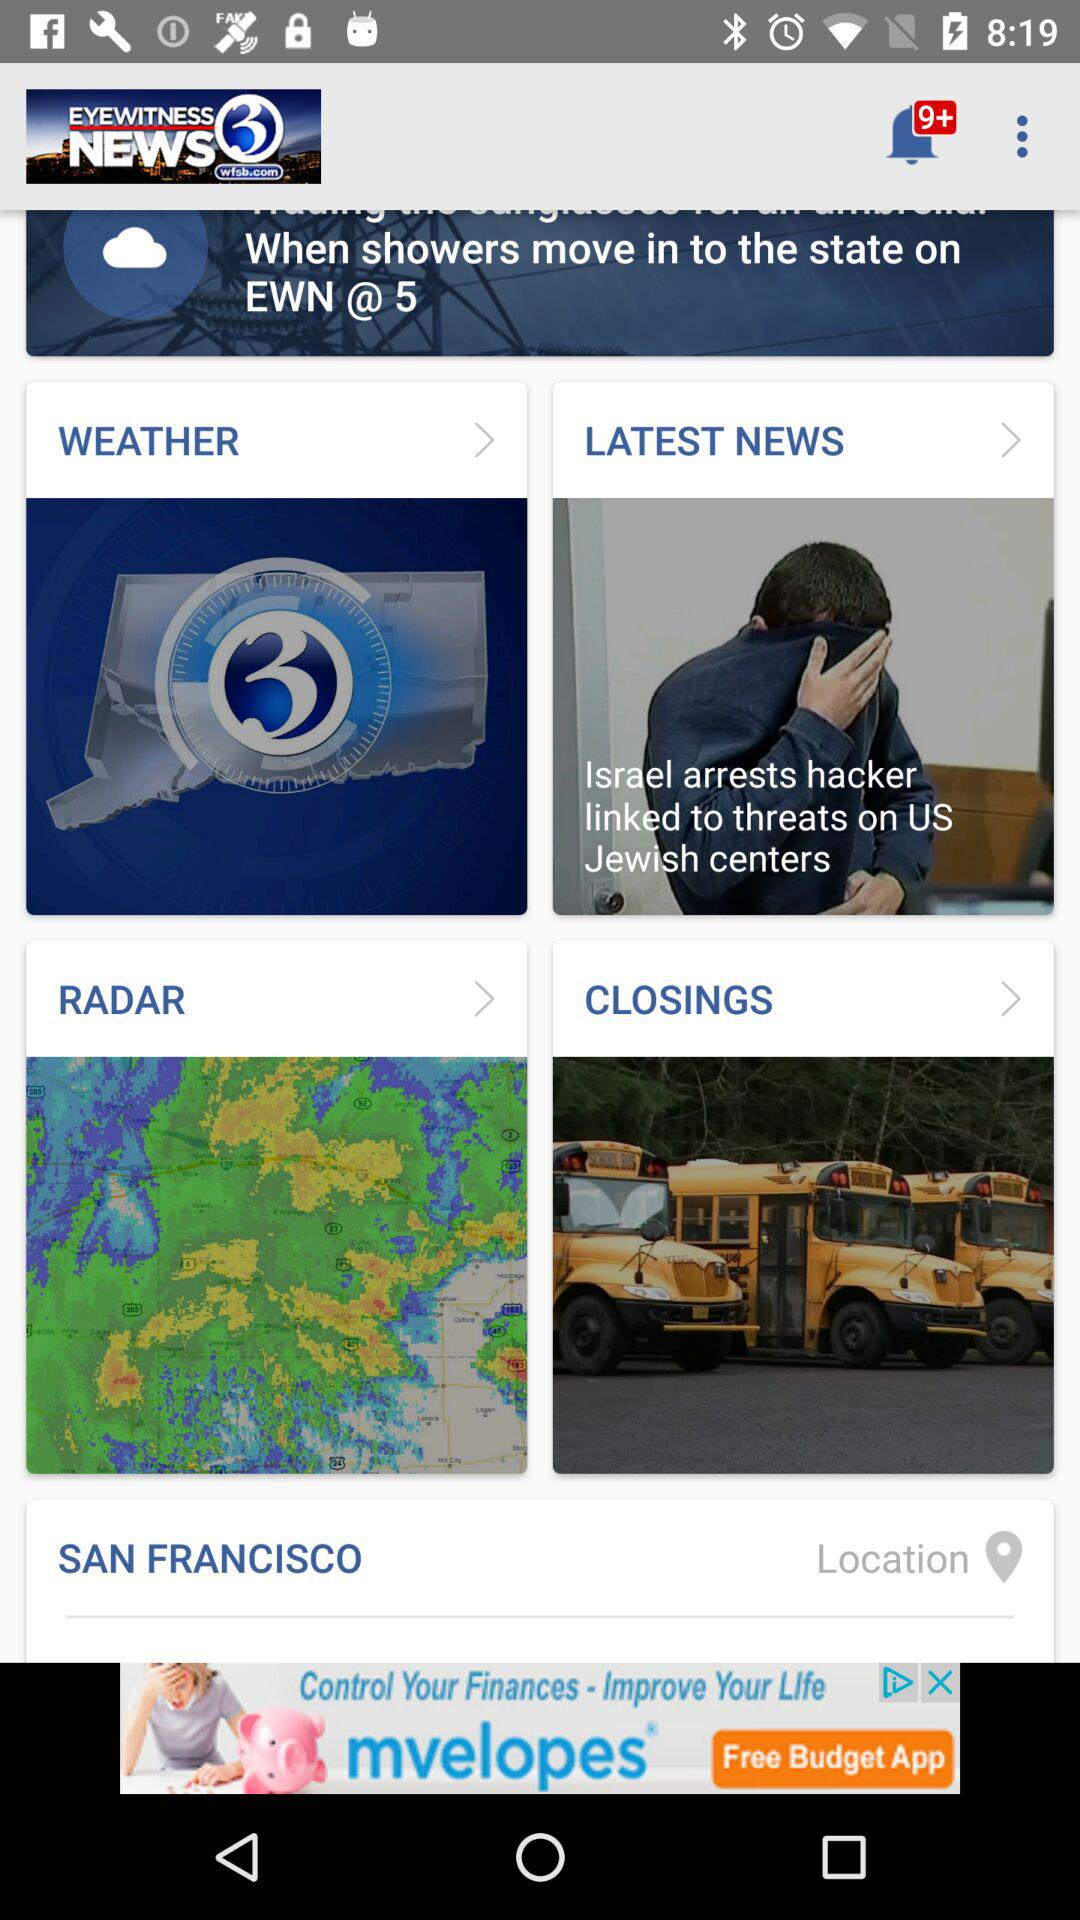What is the user name?
When the provided information is insufficient, respond with <no answer>. <no answer> 